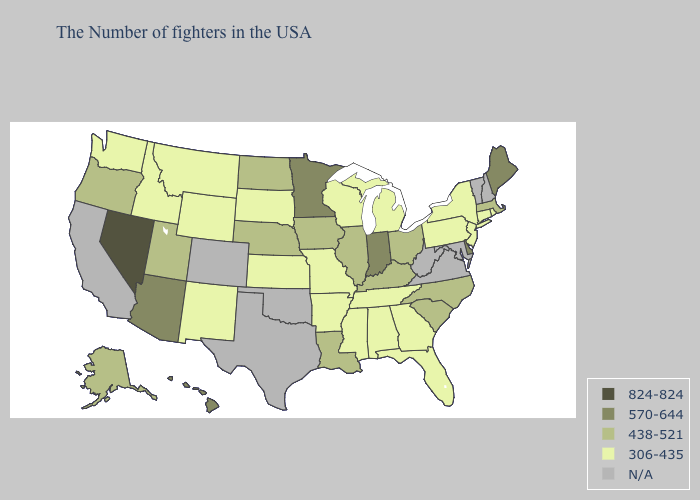What is the lowest value in states that border Indiana?
Give a very brief answer. 306-435. Does Nevada have the highest value in the USA?
Concise answer only. Yes. What is the highest value in the MidWest ?
Be succinct. 570-644. Does Minnesota have the highest value in the MidWest?
Write a very short answer. Yes. What is the lowest value in the MidWest?
Be succinct. 306-435. Name the states that have a value in the range 570-644?
Be succinct. Maine, Delaware, Indiana, Minnesota, Arizona, Hawaii. Does the map have missing data?
Be succinct. Yes. Among the states that border California , which have the lowest value?
Give a very brief answer. Oregon. Does the map have missing data?
Answer briefly. Yes. Does the map have missing data?
Keep it brief. Yes. Name the states that have a value in the range 306-435?
Concise answer only. Rhode Island, Connecticut, New York, New Jersey, Pennsylvania, Florida, Georgia, Michigan, Alabama, Tennessee, Wisconsin, Mississippi, Missouri, Arkansas, Kansas, South Dakota, Wyoming, New Mexico, Montana, Idaho, Washington. Among the states that border Connecticut , does New York have the highest value?
Keep it brief. No. Does the first symbol in the legend represent the smallest category?
Answer briefly. No. What is the lowest value in the South?
Answer briefly. 306-435. What is the value of Kentucky?
Quick response, please. 438-521. 